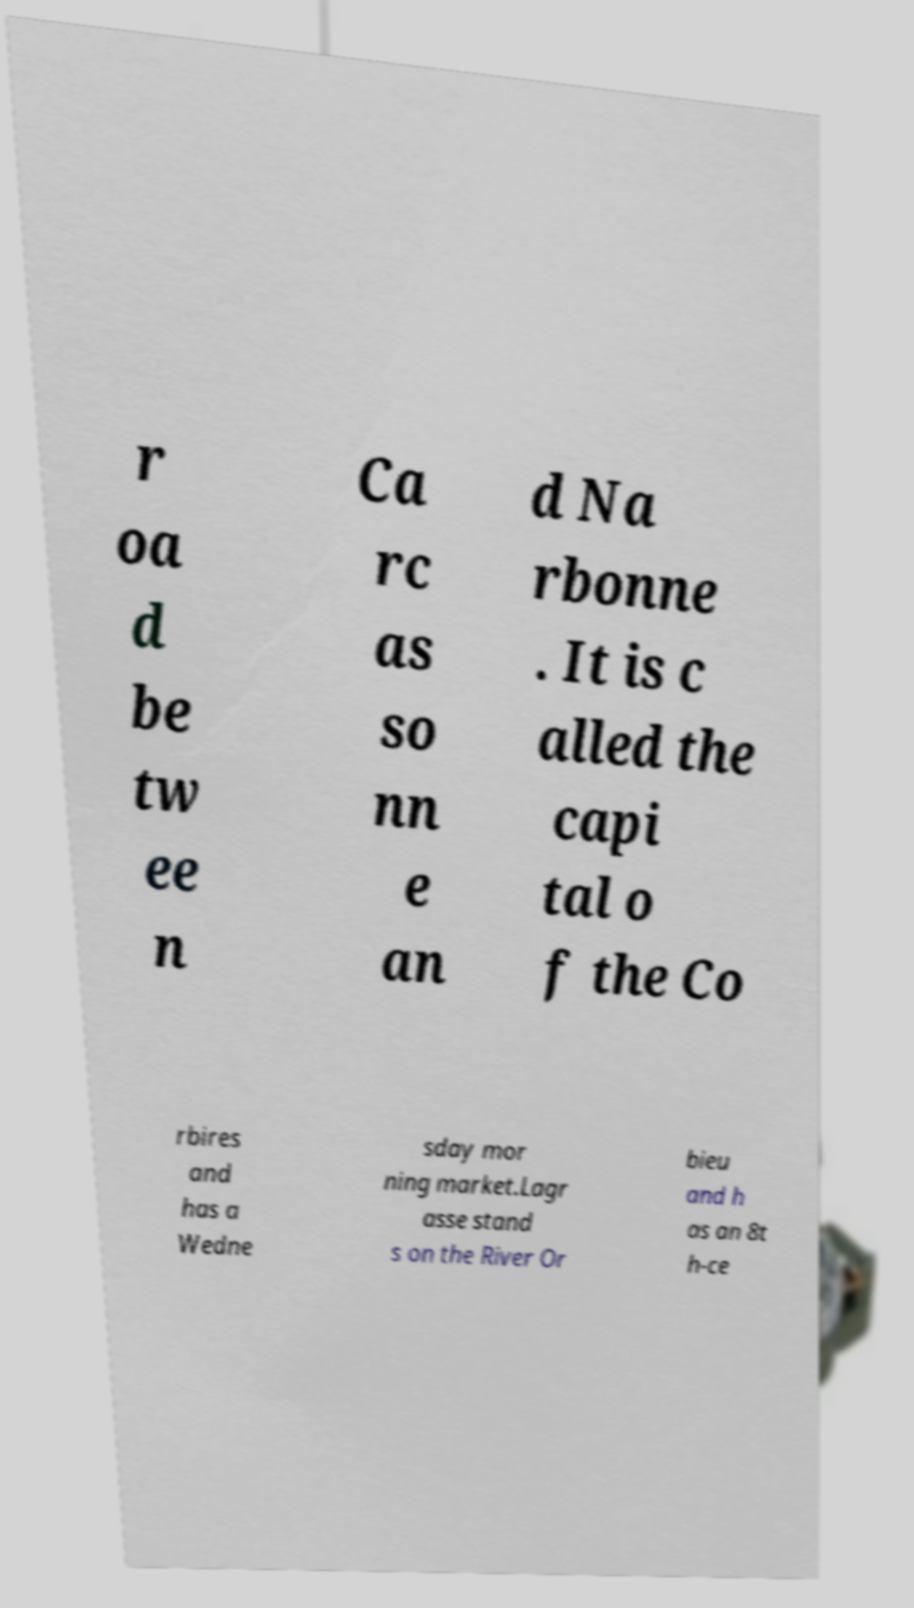Could you extract and type out the text from this image? r oa d be tw ee n Ca rc as so nn e an d Na rbonne . It is c alled the capi tal o f the Co rbires and has a Wedne sday mor ning market.Lagr asse stand s on the River Or bieu and h as an 8t h-ce 